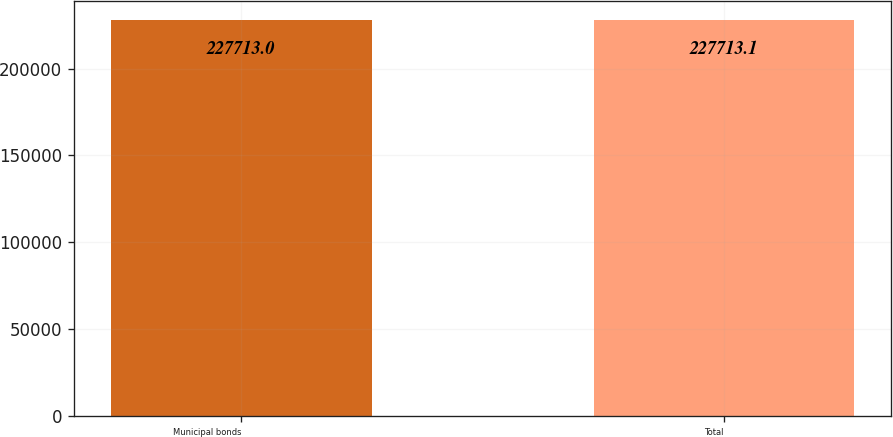<chart> <loc_0><loc_0><loc_500><loc_500><bar_chart><fcel>Municipal bonds<fcel>Total<nl><fcel>227713<fcel>227713<nl></chart> 